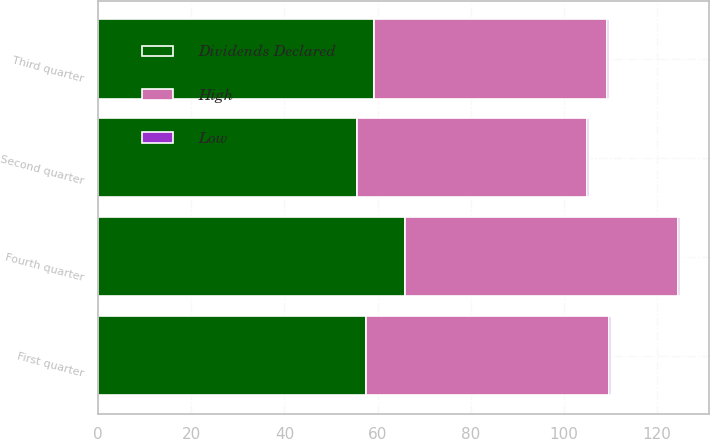<chart> <loc_0><loc_0><loc_500><loc_500><stacked_bar_chart><ecel><fcel>Fourth quarter<fcel>Third quarter<fcel>Second quarter<fcel>First quarter<nl><fcel>Dividends Declared<fcel>65.88<fcel>59.24<fcel>55.56<fcel>57.43<nl><fcel>High<fcel>58.55<fcel>50.02<fcel>49.47<fcel>52.23<nl><fcel>Low<fcel>0.44<fcel>0.44<fcel>0.44<fcel>0.44<nl></chart> 